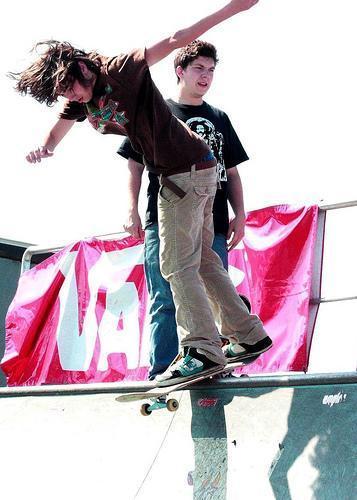How many on a skateboard?
Give a very brief answer. 1. How many people can be seen?
Give a very brief answer. 2. How many brown cows are there?
Give a very brief answer. 0. 